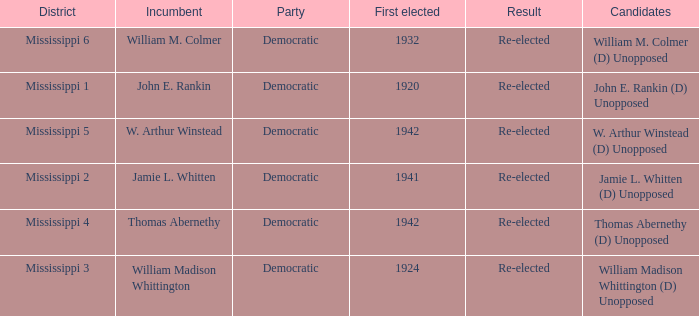What candidates are from mississippi 6? William M. Colmer (D) Unopposed. 